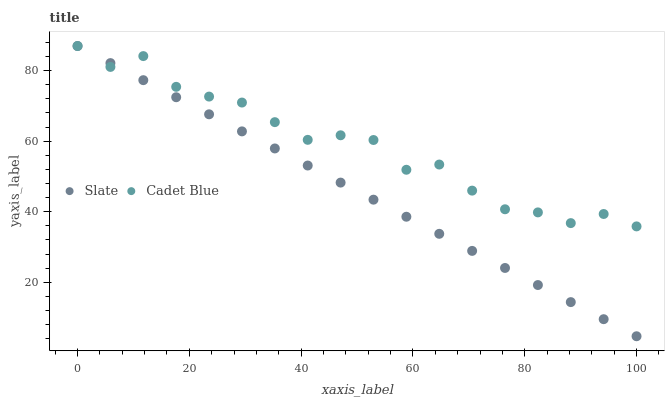Does Slate have the minimum area under the curve?
Answer yes or no. Yes. Does Cadet Blue have the maximum area under the curve?
Answer yes or no. Yes. Does Cadet Blue have the minimum area under the curve?
Answer yes or no. No. Is Slate the smoothest?
Answer yes or no. Yes. Is Cadet Blue the roughest?
Answer yes or no. Yes. Is Cadet Blue the smoothest?
Answer yes or no. No. Does Slate have the lowest value?
Answer yes or no. Yes. Does Cadet Blue have the lowest value?
Answer yes or no. No. Does Cadet Blue have the highest value?
Answer yes or no. Yes. Does Slate intersect Cadet Blue?
Answer yes or no. Yes. Is Slate less than Cadet Blue?
Answer yes or no. No. Is Slate greater than Cadet Blue?
Answer yes or no. No. 